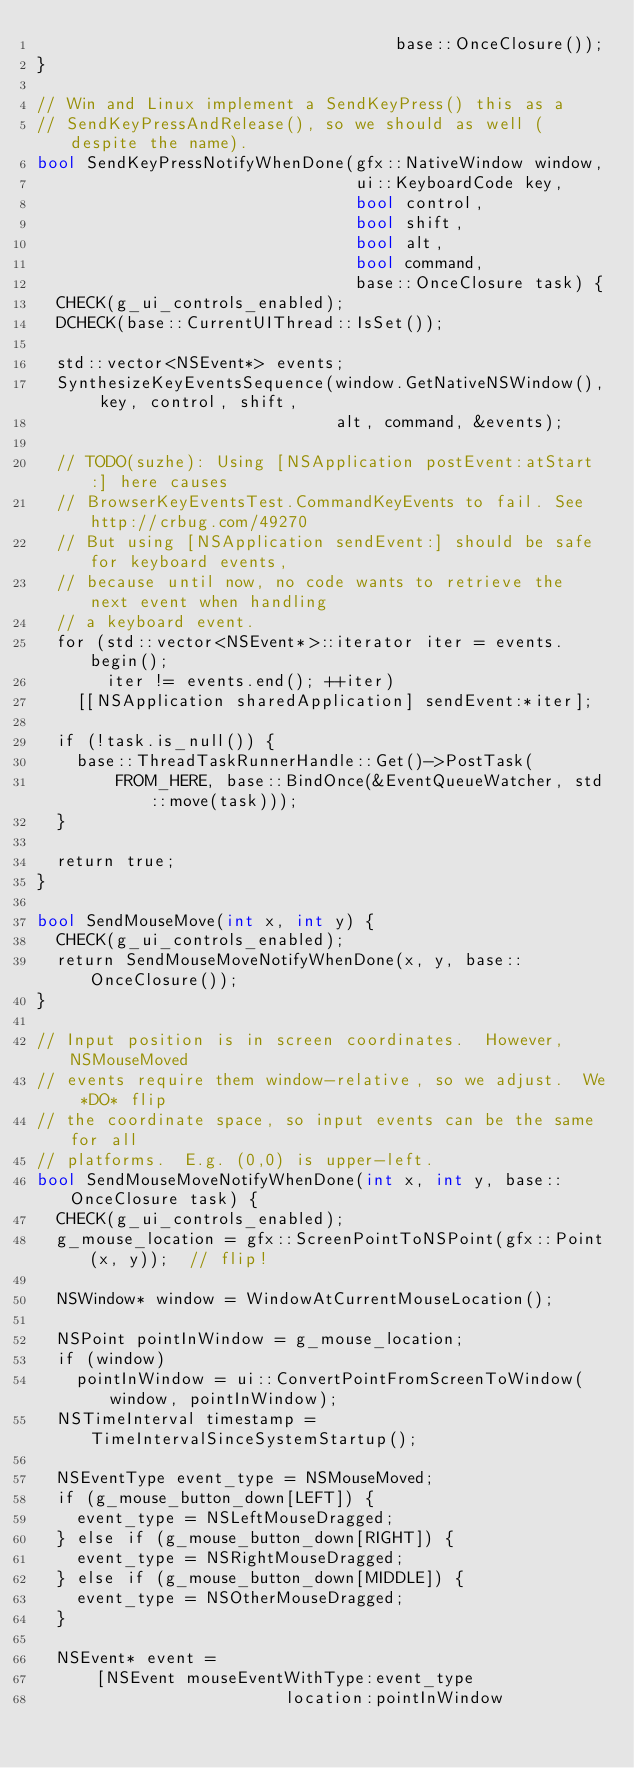<code> <loc_0><loc_0><loc_500><loc_500><_ObjectiveC_>                                    base::OnceClosure());
}

// Win and Linux implement a SendKeyPress() this as a
// SendKeyPressAndRelease(), so we should as well (despite the name).
bool SendKeyPressNotifyWhenDone(gfx::NativeWindow window,
                                ui::KeyboardCode key,
                                bool control,
                                bool shift,
                                bool alt,
                                bool command,
                                base::OnceClosure task) {
  CHECK(g_ui_controls_enabled);
  DCHECK(base::CurrentUIThread::IsSet());

  std::vector<NSEvent*> events;
  SynthesizeKeyEventsSequence(window.GetNativeNSWindow(), key, control, shift,
                              alt, command, &events);

  // TODO(suzhe): Using [NSApplication postEvent:atStart:] here causes
  // BrowserKeyEventsTest.CommandKeyEvents to fail. See http://crbug.com/49270
  // But using [NSApplication sendEvent:] should be safe for keyboard events,
  // because until now, no code wants to retrieve the next event when handling
  // a keyboard event.
  for (std::vector<NSEvent*>::iterator iter = events.begin();
       iter != events.end(); ++iter)
    [[NSApplication sharedApplication] sendEvent:*iter];

  if (!task.is_null()) {
    base::ThreadTaskRunnerHandle::Get()->PostTask(
        FROM_HERE, base::BindOnce(&EventQueueWatcher, std::move(task)));
  }

  return true;
}

bool SendMouseMove(int x, int y) {
  CHECK(g_ui_controls_enabled);
  return SendMouseMoveNotifyWhenDone(x, y, base::OnceClosure());
}

// Input position is in screen coordinates.  However, NSMouseMoved
// events require them window-relative, so we adjust.  We *DO* flip
// the coordinate space, so input events can be the same for all
// platforms.  E.g. (0,0) is upper-left.
bool SendMouseMoveNotifyWhenDone(int x, int y, base::OnceClosure task) {
  CHECK(g_ui_controls_enabled);
  g_mouse_location = gfx::ScreenPointToNSPoint(gfx::Point(x, y));  // flip!

  NSWindow* window = WindowAtCurrentMouseLocation();

  NSPoint pointInWindow = g_mouse_location;
  if (window)
    pointInWindow = ui::ConvertPointFromScreenToWindow(window, pointInWindow);
  NSTimeInterval timestamp = TimeIntervalSinceSystemStartup();

  NSEventType event_type = NSMouseMoved;
  if (g_mouse_button_down[LEFT]) {
    event_type = NSLeftMouseDragged;
  } else if (g_mouse_button_down[RIGHT]) {
    event_type = NSRightMouseDragged;
  } else if (g_mouse_button_down[MIDDLE]) {
    event_type = NSOtherMouseDragged;
  }

  NSEvent* event =
      [NSEvent mouseEventWithType:event_type
                         location:pointInWindow</code> 